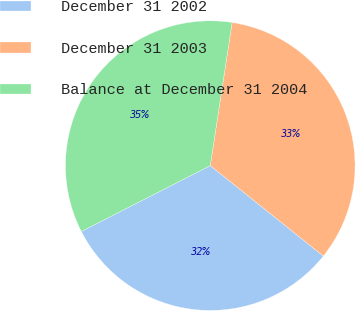Convert chart to OTSL. <chart><loc_0><loc_0><loc_500><loc_500><pie_chart><fcel>December 31 2002<fcel>December 31 2003<fcel>Balance at December 31 2004<nl><fcel>31.75%<fcel>33.33%<fcel>34.92%<nl></chart> 